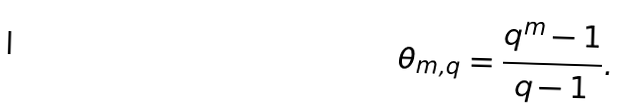<formula> <loc_0><loc_0><loc_500><loc_500>\theta _ { m , q } = \frac { q ^ { m } - 1 } { q - 1 } .</formula> 